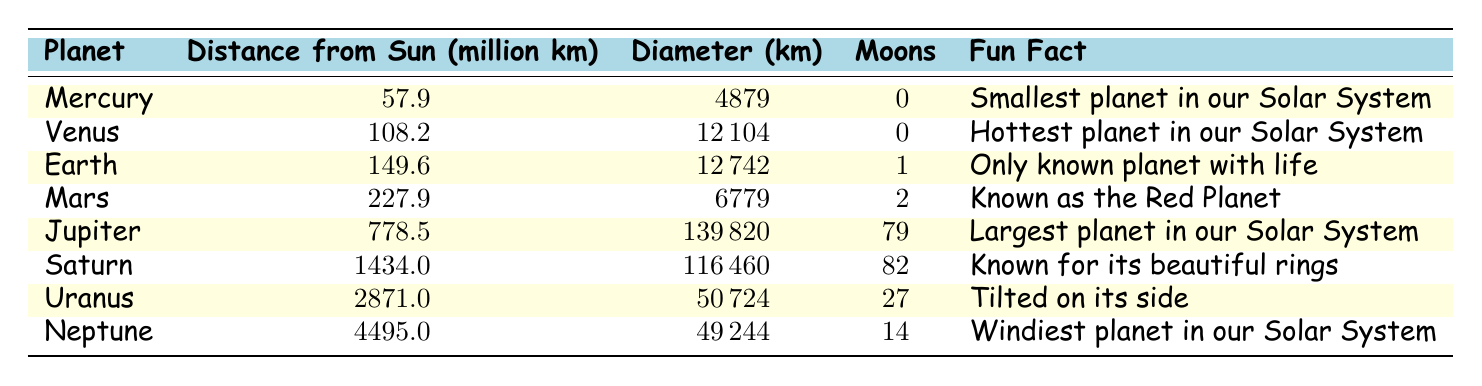What planet has the largest diameter? From the table, Jupiter has a diameter of 139820 km, which is larger than the diameters of all other planets listed.
Answer: Jupiter How many moons does Saturn have? According to the table, Saturn has 82 moons listed next to its name in the moons column.
Answer: 82 Which planet is the farthest from the Sun? The table shows Neptune with a distance of 4495.0 million km from the Sun, which is greater than that of all other planets.
Answer: Neptune True or False: Mercury has more moons than Earth. By comparing the moons column, Mercury has 0 moons while Earth has 1 moon, making the statement false.
Answer: False What is the average distance from the Sun for the terrestrial planets (Mercury, Venus, Earth, and Mars)? The distances from the Sun for the terrestrial planets are 57.9 (Mercury), 108.2 (Venus), 149.6 (Earth), and 227.9 (Mars). Summing them gives 57.9 + 108.2 + 149.6 + 227.9 = 543.6 million km. Since there are 4 planets, the average is 543.6 / 4 = 135.9 million km.
Answer: 135.9 Which planet has the fewest moons among the terrestrial planets? The terrestrial planets in the table are Mercury, Venus, Earth, and Mars. From the moons column, Mercury and Venus have 0 moons, while Earth has 1 and Mars has 2. Therefore, both Mercury and Venus have the fewest moons, which is 0.
Answer: Mercury and Venus How do the diameters of Jupiter and Saturn compare? Jupiter has a diameter of 139820 km and Saturn has a diameter of 116460 km. Comparing these two values, Jupiter's diameter is larger by 139820 - 116460 = 23360 km.
Answer: Jupiter is larger by 23360 km What is the total number of moons for all the planets in our Solar System? To find the total, sum the moons for each planet listed: 0 (Mercury) + 0 (Venus) + 1 (Earth) + 2 (Mars) + 79 (Jupiter) + 82 (Saturn) + 27 (Uranus) + 14 (Neptune) = 205 moons in total.
Answer: 205 